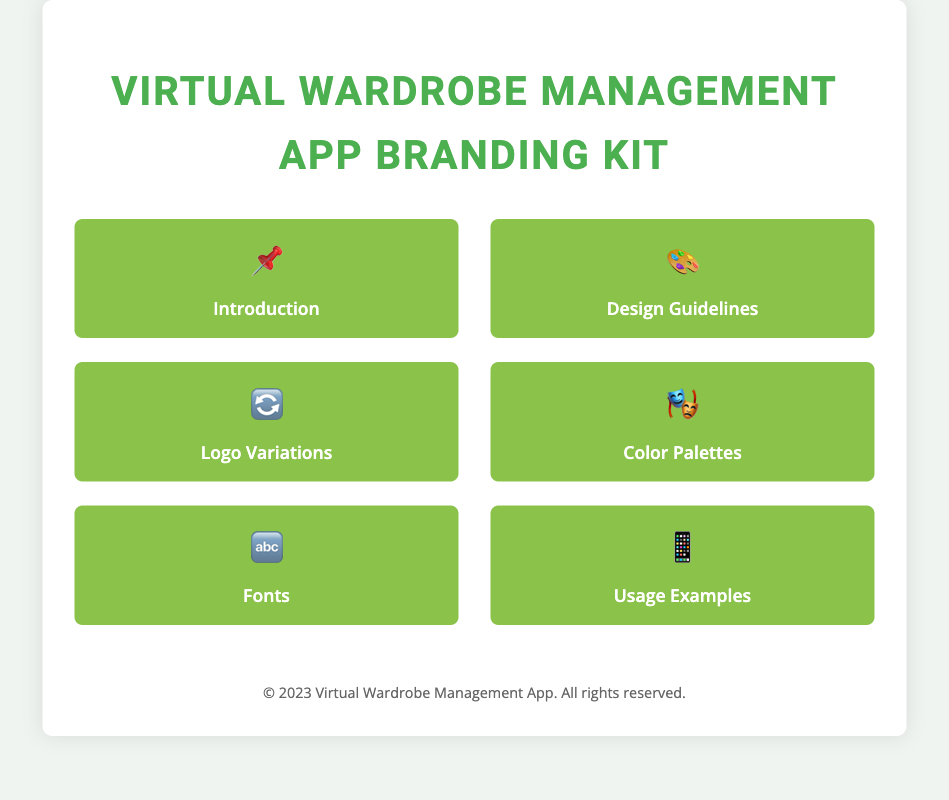What is the title of the document? The title of the document is specified in the `<title>` tag, which is "Virtual Wardrobe Management App Branding Kit."
Answer: Virtual Wardrobe Management App Branding Kit How many main sections are listed in the index? The number of main sections can be counted from the index list, which contains six items: Introduction, Design Guidelines, Logo Variations, Color Palettes, Fonts, and Usage Examples.
Answer: 6 Which color is used for the headings? The color for headings is defined in the CSS style for `h1`, where it is set to `#4CAF50`.
Answer: #4CAF50 What is the background color of the container? The background color of the container is specified in the CSS for `.container`, which is `#ffffff`.
Answer: #ffffff What type of questions does the index include? The index includes various sections for design guidelines, logo variations, color palettes, fonts, and usage examples. The content is structured to facilitate quick access to key topics.
Answer: Design guidelines, logo variations, color palettes, fonts, usage examples How are the index items formatted visually? The index items are formatted to have a green background color, rounded corners, and a transition effect on hover as per the CSS styling.
Answer: Green background, rounded corners, hover effect 